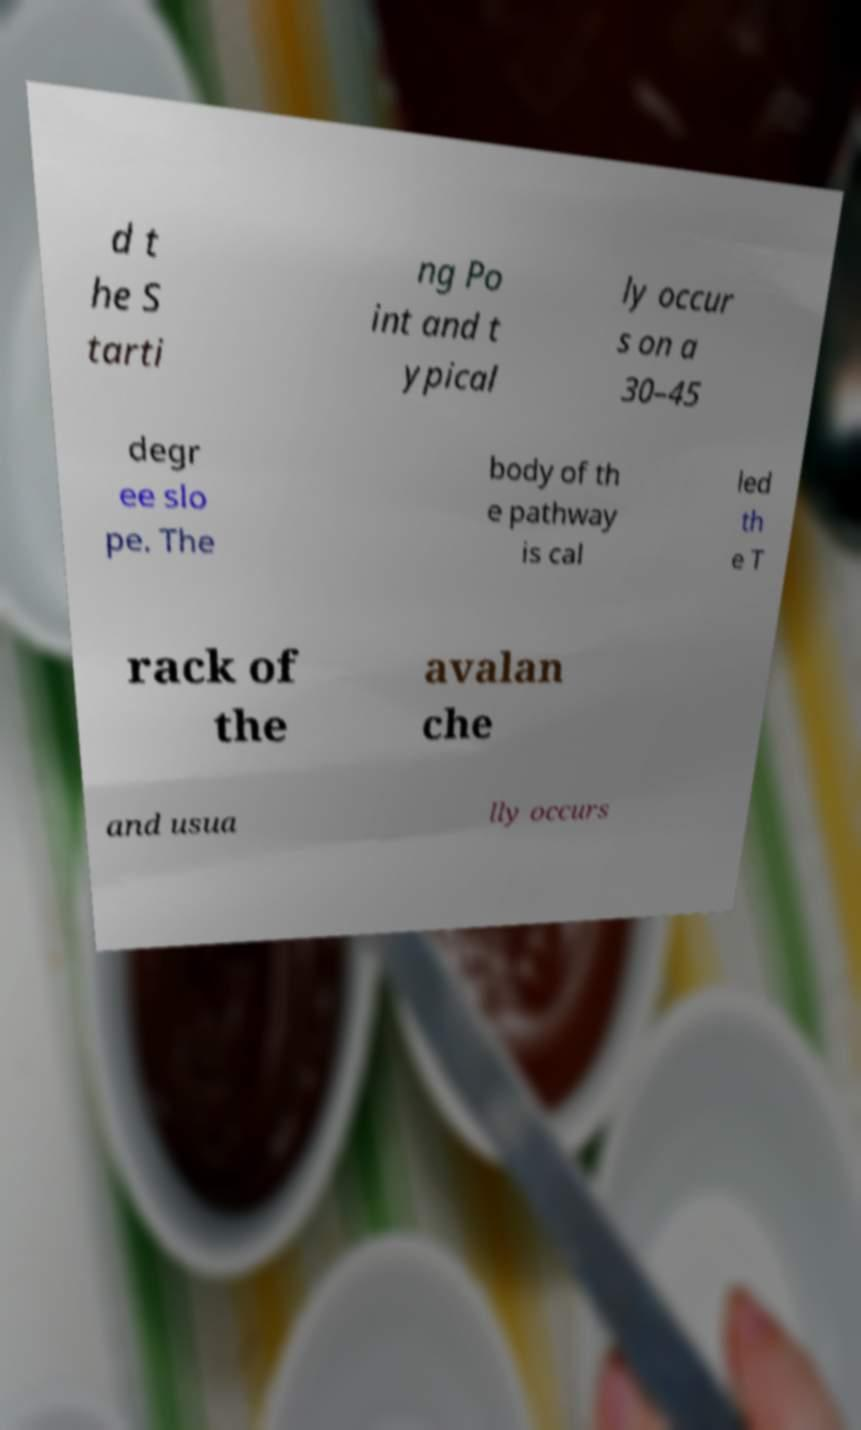Please read and relay the text visible in this image. What does it say? d t he S tarti ng Po int and t ypical ly occur s on a 30–45 degr ee slo pe. The body of th e pathway is cal led th e T rack of the avalan che and usua lly occurs 